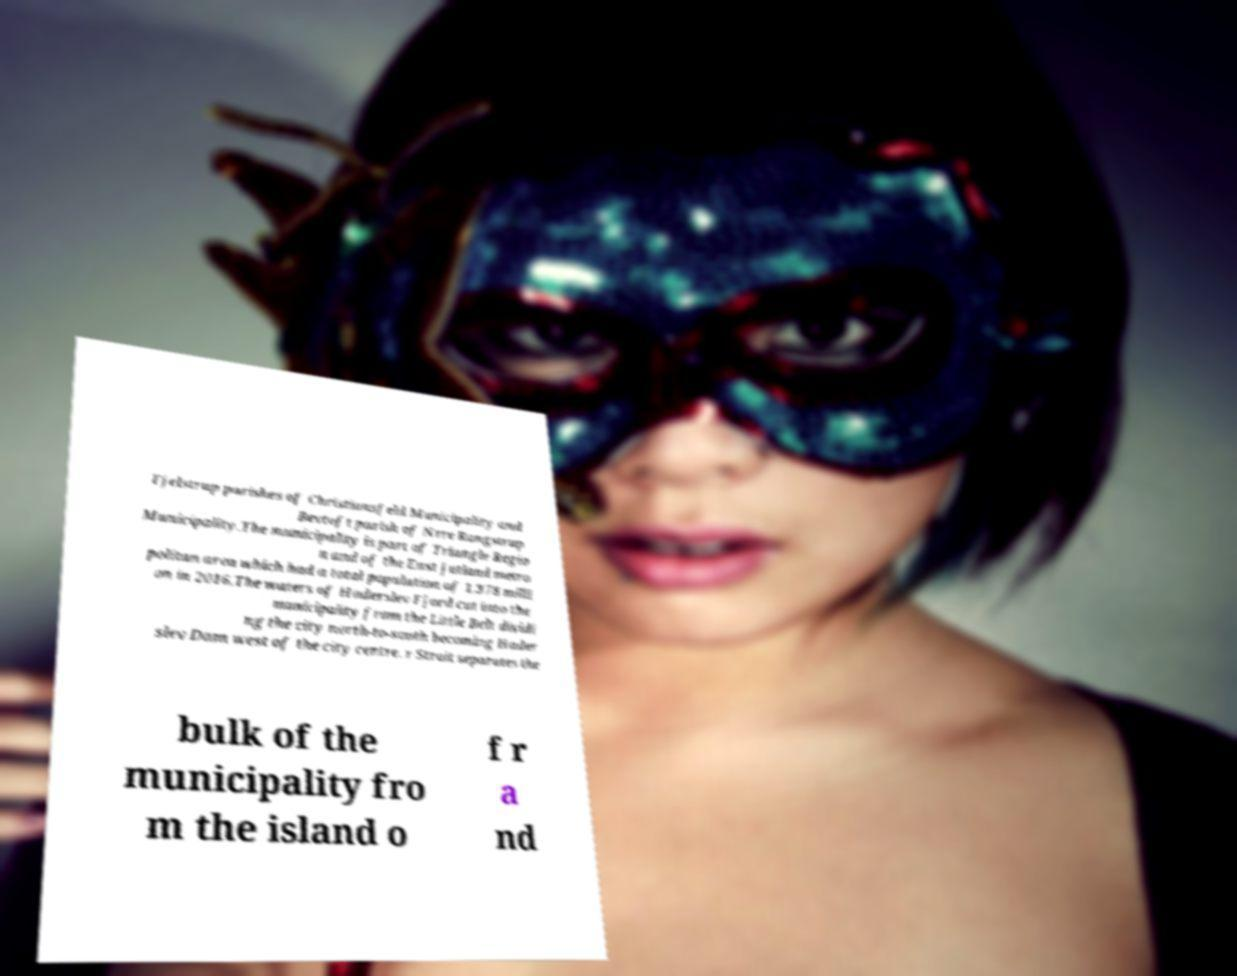Please identify and transcribe the text found in this image. Fjelstrup parishes of Christiansfeld Municipality and Bevtoft parish of Nrre Rangstrup Municipality.The municipality is part of Triangle Regio n and of the East Jutland metro politan area which had a total population of 1.378 milli on in 2016.The waters of Haderslev Fjord cut into the municipality from the Little Belt dividi ng the city north-to-south becoming Hader slev Dam west of the city centre. r Strait separates the bulk of the municipality fro m the island o f r a nd 